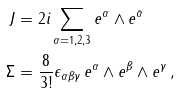Convert formula to latex. <formula><loc_0><loc_0><loc_500><loc_500>J & = 2 i \sum _ { \alpha = 1 , 2 , 3 } e ^ { \alpha } \wedge e ^ { \bar { \alpha } } \, \\ \Sigma & = \frac { 8 } { 3 ! } \epsilon _ { \alpha \beta \gamma } \, e ^ { \alpha } \wedge e ^ { \beta } \wedge e ^ { \gamma } \, ,</formula> 